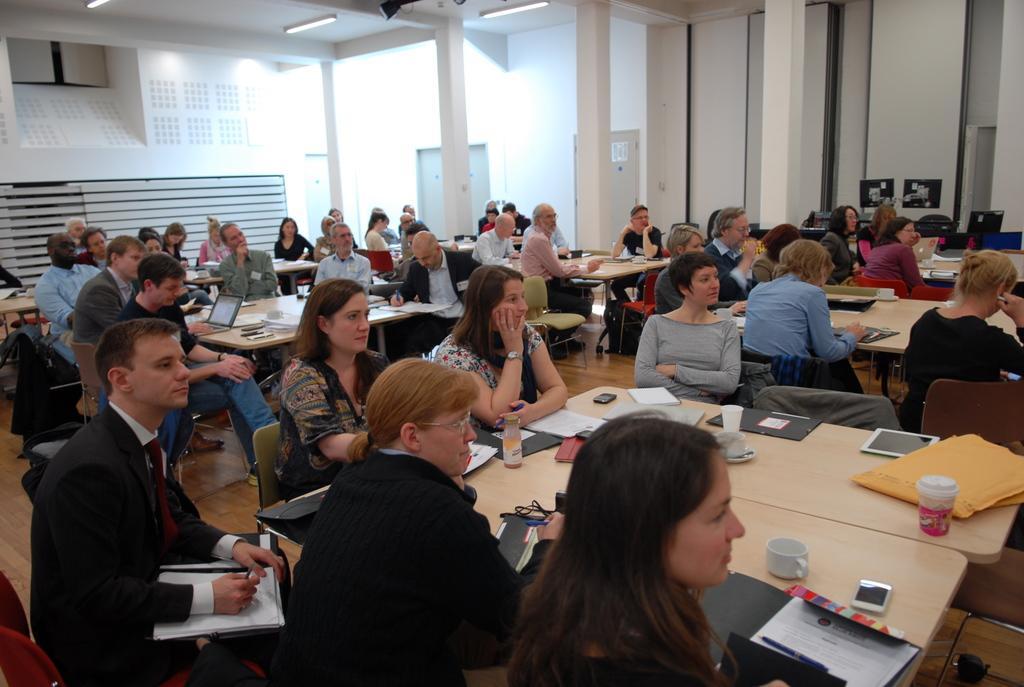Describe this image in one or two sentences. There are many persons sitting in this room. There are tables, chairs in this room. On the table there are tab, laptop, books, bottles, cups, mobile, papers, pen and ,many other item. In the background there are pillars, walls and window 